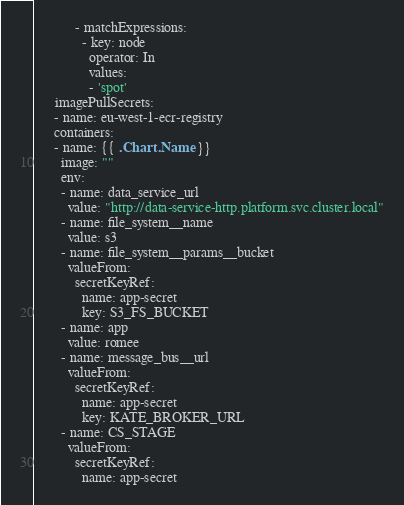<code> <loc_0><loc_0><loc_500><loc_500><_YAML_>            - matchExpressions:
              - key: node
                operator: In
                values:
                - 'spot'
      imagePullSecrets:
      - name: eu-west-1-ecr-registry
      containers:
      - name: {{ .Chart.Name  }}
        image: ""
        env:
        - name: data_service_url
          value: "http://data-service-http.platform.svc.cluster.local"
        - name: file_system__name
          value: s3
        - name: file_system__params__bucket
          valueFrom:
            secretKeyRef:
              name: app-secret
              key: S3_FS_BUCKET
        - name: app
          value: romee
        - name: message_bus__url
          valueFrom:
            secretKeyRef:
              name: app-secret
              key: KATE_BROKER_URL
        - name: CS_STAGE
          valueFrom:
            secretKeyRef:
              name: app-secret</code> 